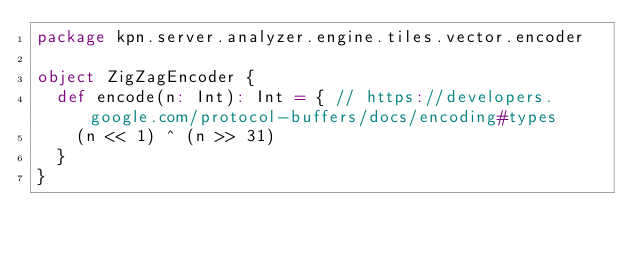Convert code to text. <code><loc_0><loc_0><loc_500><loc_500><_Scala_>package kpn.server.analyzer.engine.tiles.vector.encoder

object ZigZagEncoder {
  def encode(n: Int): Int = { // https://developers.google.com/protocol-buffers/docs/encoding#types
    (n << 1) ^ (n >> 31)
  }
}
</code> 